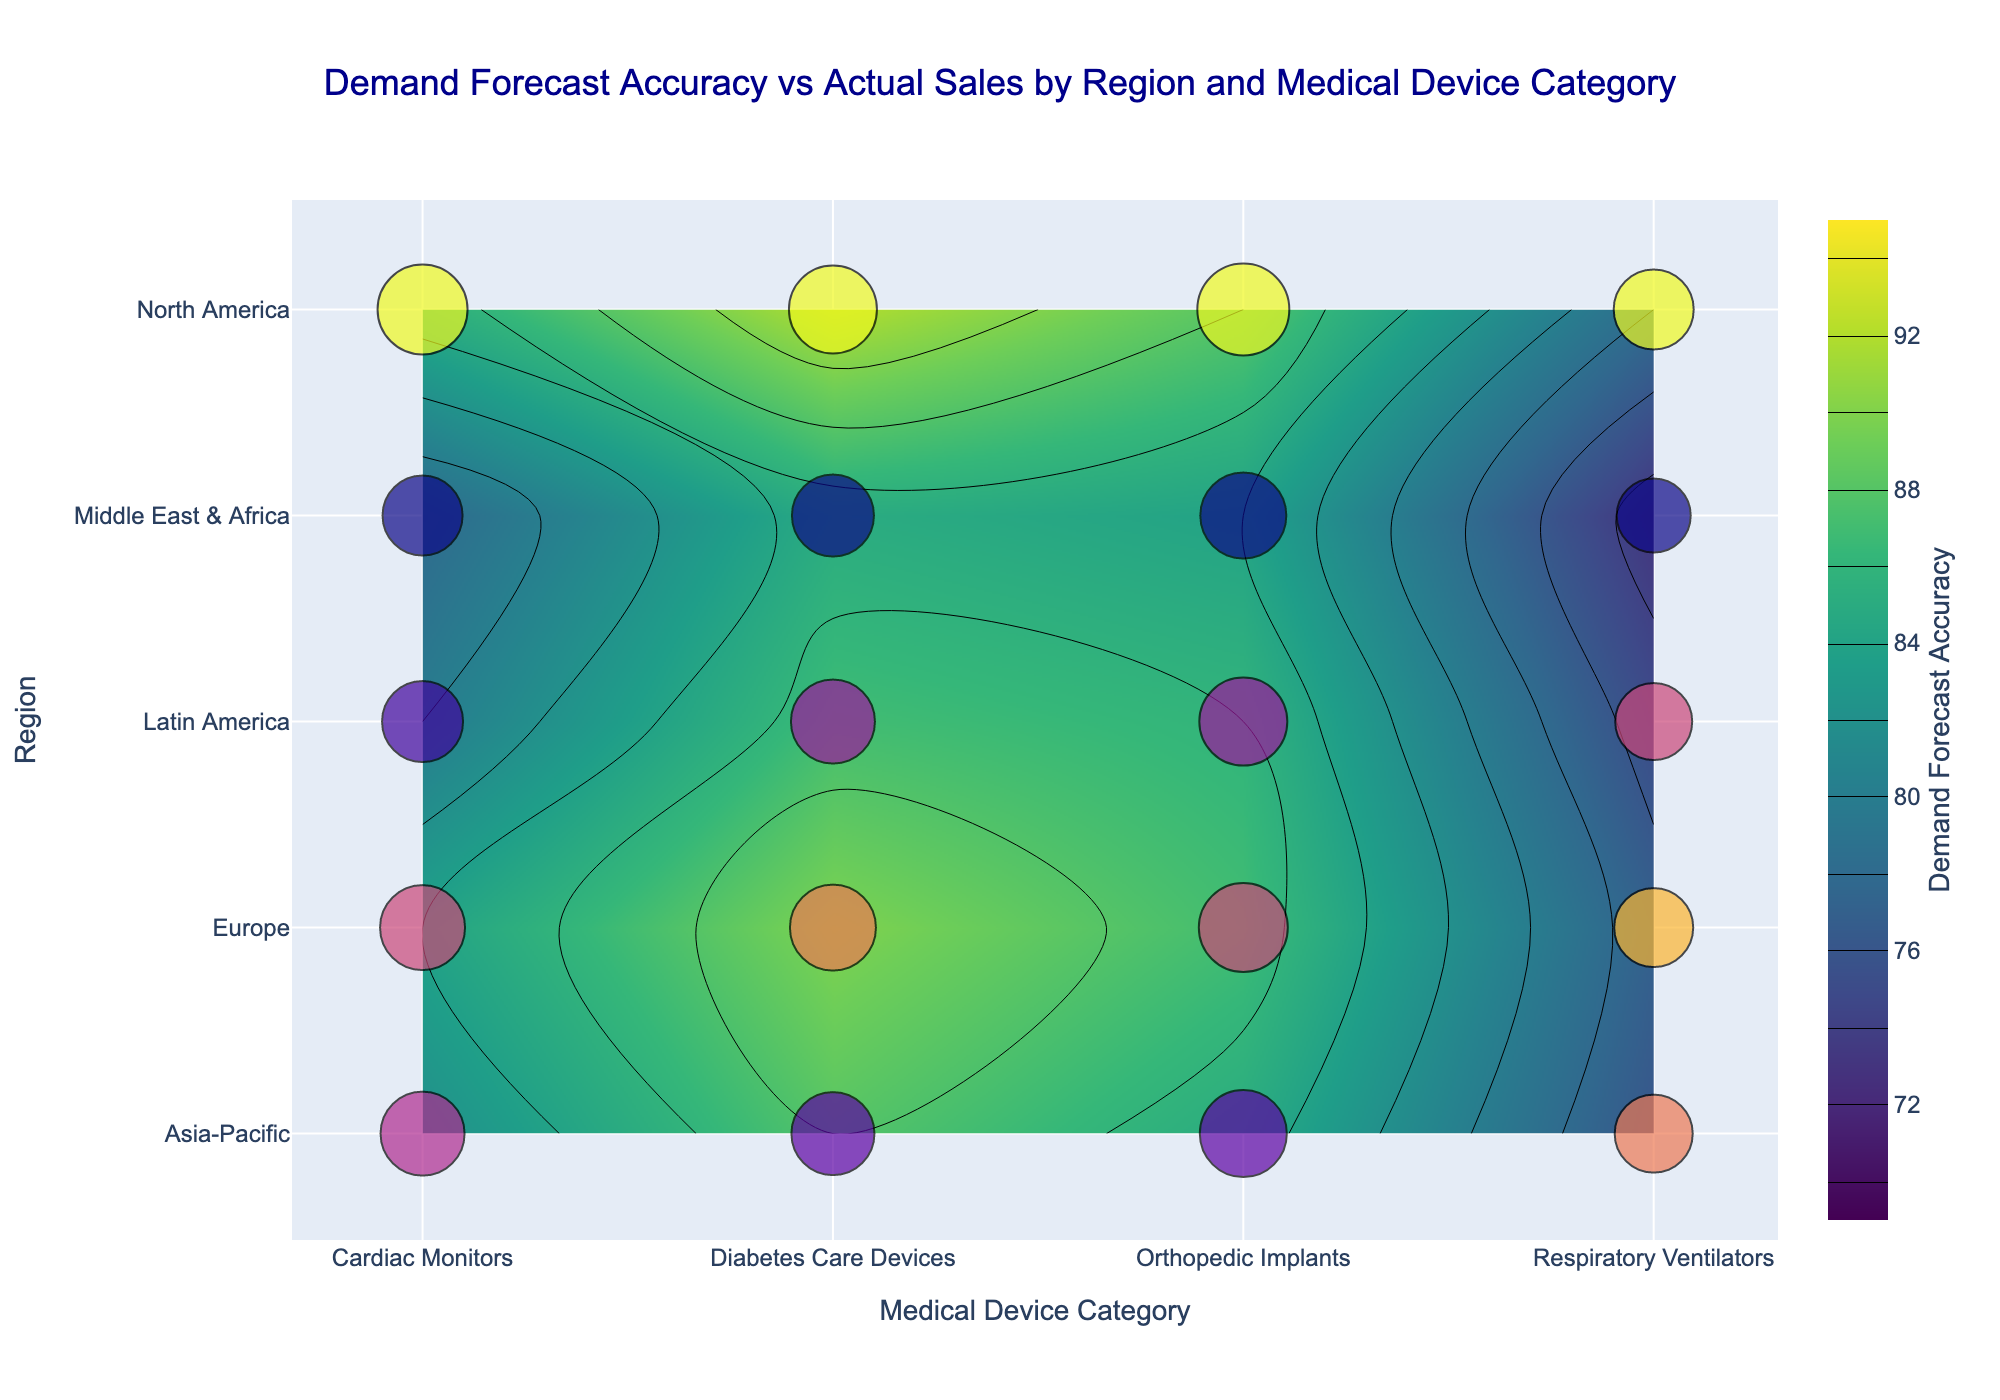What's the title of the figure? The title usually appears at the top of the figure and summarizes what the plot is about. For this figure, it should be visible near the top center.
Answer: Demand Forecast Accuracy vs Actual Sales by Region and Medical Device Category Which region has the highest demand forecast accuracy for Cardiac Monitors? By looking at the contour plot and the color scale, locate the "Cardiac Monitors" category on the x-axis and find the region on the y-axis with the darkest color indicating the highest accuracy.
Answer: North America Compare the actual sales for Diabetes Care Devices in North America and Europe. Which one is higher? Observe the scatter plot markers for Diabetes Care Devices at these two regions; larger markers indicate higher sales and the color intensity can also guide the comparison.
Answer: North America What's the range of the Demand Forecast Accuracy values displayed in the contour plot? The color scale on the right side of the plot can be referred to. It shows the range from the lowest to the highest value.
Answer: 70 to 95 Which Medical Device Category has the smallest range of Demand Forecast Accuracy across all regions? Compare the spread in the color (contour plot) for each category along the x-axis; the category with the least variation (smallest color gradient) has the smallest range.
Answer: Respiratory Ventilators Between Orthopedic Implants in Europe and Latin America, which has closer actual sales to its forecast? Look at the markers for Orthopedic Implants in these regions and compare their size and color; then, approximate how close they are to their respective forecast accuracy.
Answer: Latin America How does the forecast accuracy for Respiratory Ventilators in the Middle East & Africa compare to its actual sales? Locate the Respiratory Ventilators category and the Middle East & Africa region; compare the contour plot color (accuracy) and the scatter plot marker size and color (sales).
Answer: The forecast accuracy is 73, while actual sales are 74 In which region do Orthopedic Implants have the highest forecast accuracy? Locate the Orthopedic Implants category and identify the region with the darkest color in the contour plot section for this category.
Answer: North America What patterns or trends can you infer about the demand forecast accuracy for Cardiac Monitors across different regions? Compare the colors in the contour plot along the x-axis category 'Cardiac Monitors' for each region to infer consistent trends or variability.
Answer: The forecast accuracy is highest in North America and decreases across other regions, with Middle East & Africa having the lowest Is there any Medical Device Category where actual sales consistently exceed forecast accuracy across regions? Compare the size and color of scatter plot markers across regions to the colors in the contour plot for each category and find if one shows consistently higher actual sales.
Answer: Orthopedic Implants 